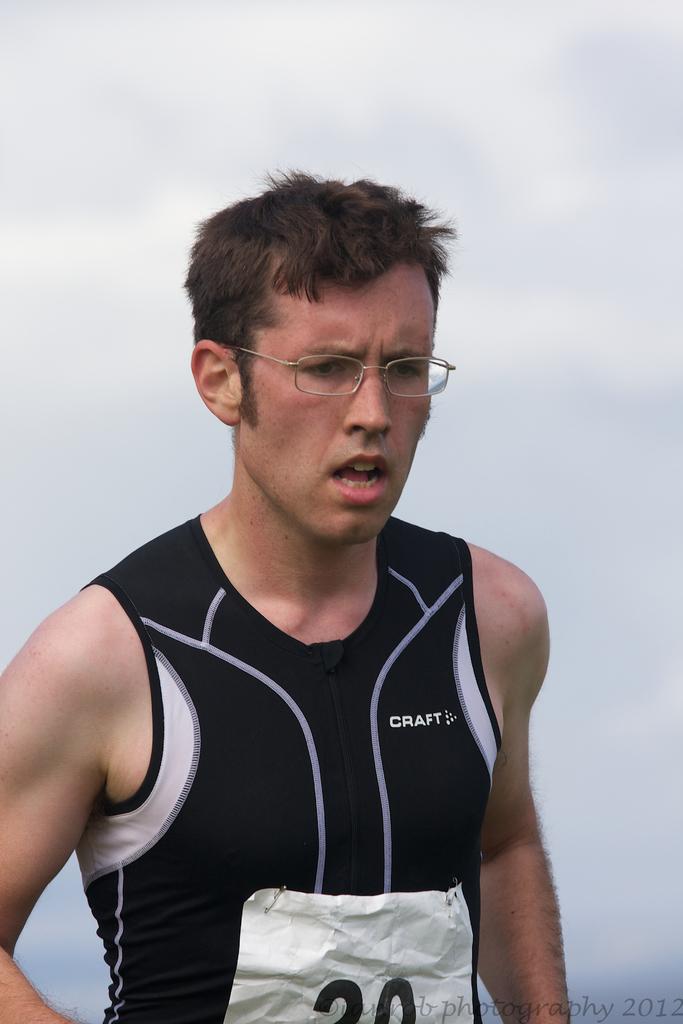What number is the runner?
Your answer should be very brief. 20. 